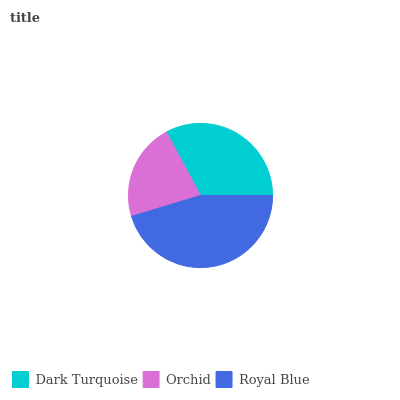Is Orchid the minimum?
Answer yes or no. Yes. Is Royal Blue the maximum?
Answer yes or no. Yes. Is Royal Blue the minimum?
Answer yes or no. No. Is Orchid the maximum?
Answer yes or no. No. Is Royal Blue greater than Orchid?
Answer yes or no. Yes. Is Orchid less than Royal Blue?
Answer yes or no. Yes. Is Orchid greater than Royal Blue?
Answer yes or no. No. Is Royal Blue less than Orchid?
Answer yes or no. No. Is Dark Turquoise the high median?
Answer yes or no. Yes. Is Dark Turquoise the low median?
Answer yes or no. Yes. Is Royal Blue the high median?
Answer yes or no. No. Is Royal Blue the low median?
Answer yes or no. No. 